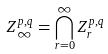Convert formula to latex. <formula><loc_0><loc_0><loc_500><loc_500>Z _ { \infty } ^ { p , q } = \bigcap _ { r = 0 } ^ { \infty } Z _ { r } ^ { p , q }</formula> 